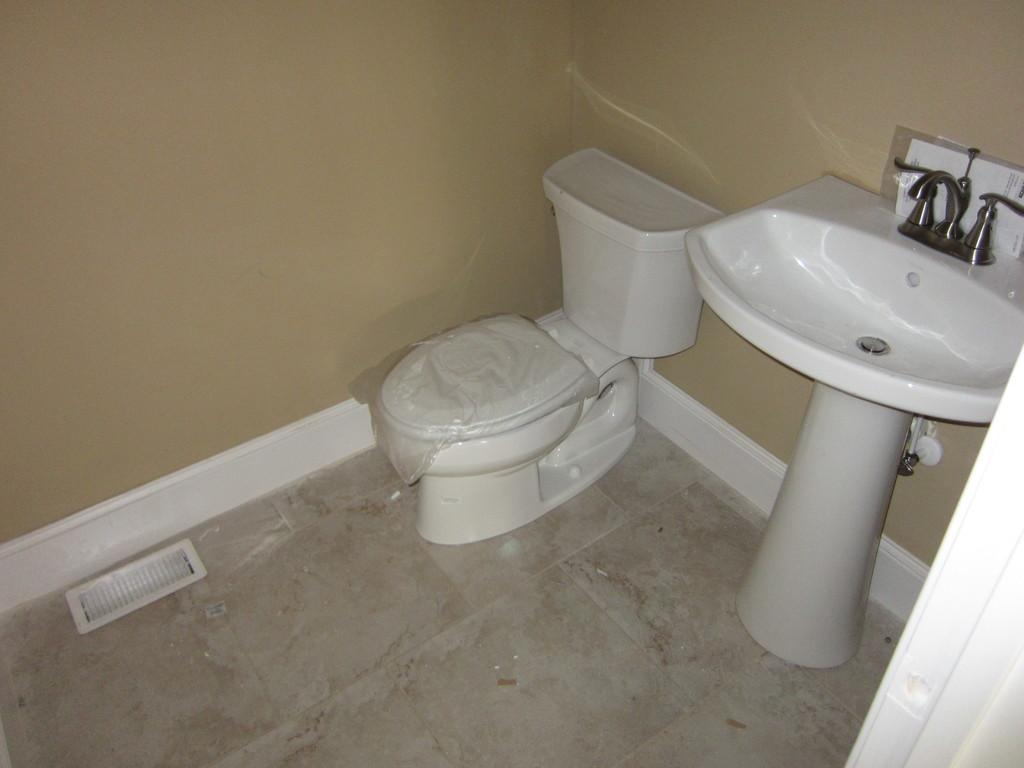What is the main object in the image? There is a toilet bowl in the image. What other object related to personal hygiene can be seen in the image? There is a wash basin in the image. What type of structure is visible in the background? There is a wall in the image. Can we assume that the image was taken in a specific type of room? The image might have been taken in a room, possibly a bathroom, given the presence of a toilet bowl and wash basin. How many jellyfish can be seen swimming in the toilet bowl in the image? There are no jellyfish present in the image; the toilet bowl contains no living organisms. 